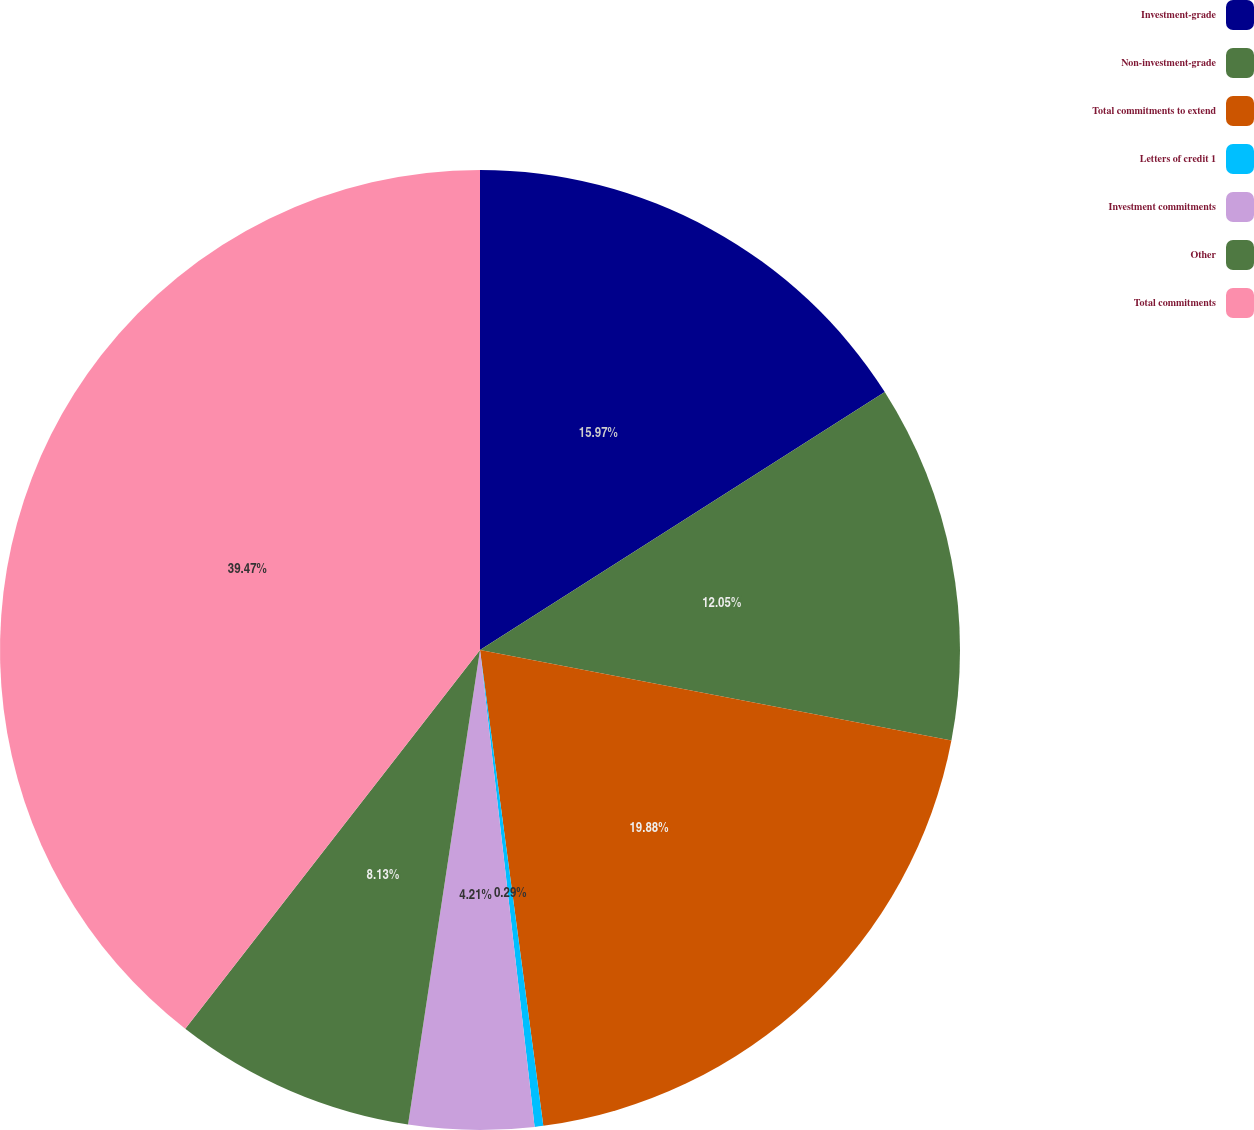Convert chart. <chart><loc_0><loc_0><loc_500><loc_500><pie_chart><fcel>Investment-grade<fcel>Non-investment-grade<fcel>Total commitments to extend<fcel>Letters of credit 1<fcel>Investment commitments<fcel>Other<fcel>Total commitments<nl><fcel>15.97%<fcel>12.05%<fcel>19.88%<fcel>0.29%<fcel>4.21%<fcel>8.13%<fcel>39.48%<nl></chart> 